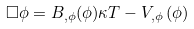<formula> <loc_0><loc_0><loc_500><loc_500>\square \phi = B _ { , \phi } ( \phi ) \kappa T - V _ { , \phi } \left ( \phi \right )</formula> 